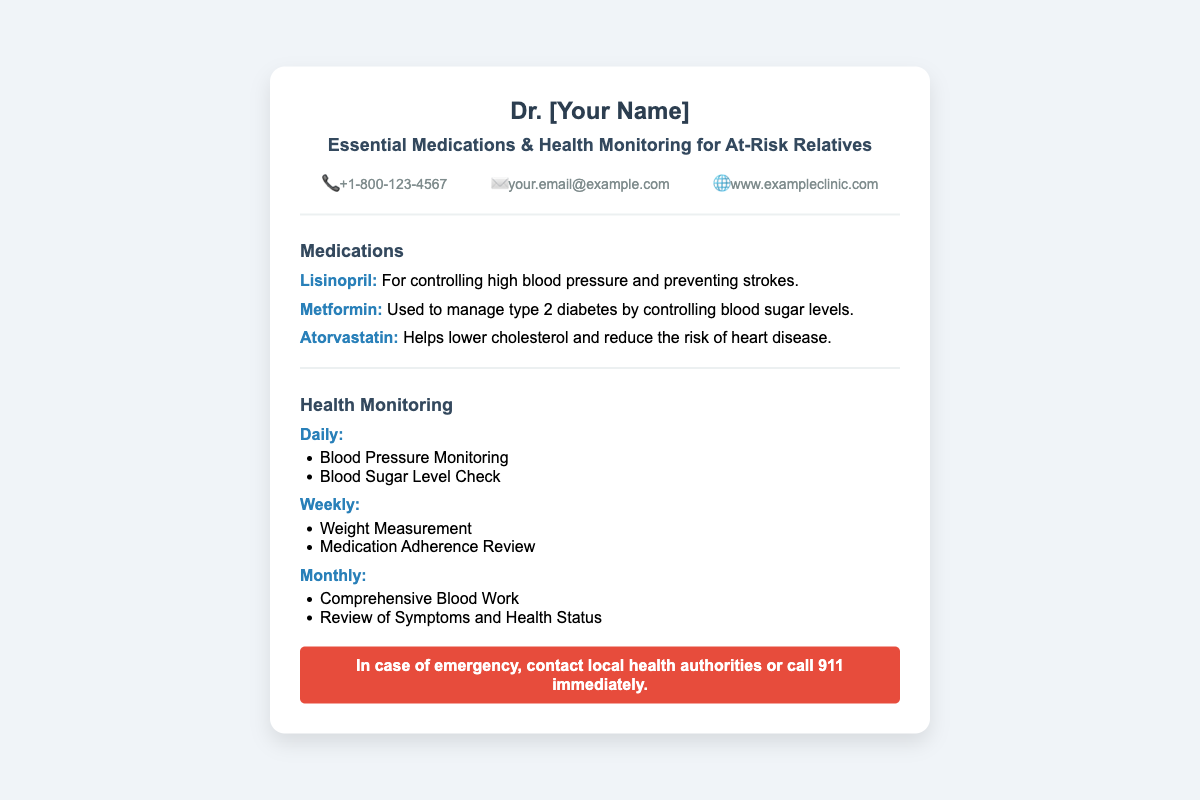what is the name of the doctor? The document presents the name of the doctor in the header section, which is labeled as "Dr. [Your Name]".
Answer: Dr. [Your Name] what is the first medication listed? The first medication mentioned in the medications section is the one that appears at the top of the list.
Answer: Lisinopril how often should blood pressure be monitored? The frequency of blood pressure monitoring is specified in the health monitoring section, categorized as 'Daily'.
Answer: Daily what is the contact phone number? The contact information includes a phone number, which is clearly stated in the contact-info section of the card.
Answer: +1-800-123-4567 which medication is used for diabetes management? The medication specifically noted for managing diabetes is identified in the document under the medications section.
Answer: Metformin how many types of health monitoring are specified? The document lists different categories of health monitoring, providing a total count of the distinct types outlined.
Answer: Three what is the color of the emergency section? The emergency section features a distinct background color that is described in the styling of the card.
Answer: Red what type of health status review is done monthly? The health monitoring section specifies a particular review that is combined with comprehensive blood work mentioned for the monthly category.
Answer: Review of Symptoms and Health Status 